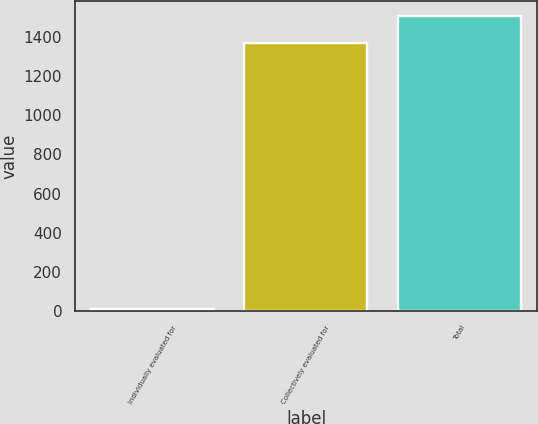Convert chart. <chart><loc_0><loc_0><loc_500><loc_500><bar_chart><fcel>Individually evaluated for<fcel>Collectively evaluated for<fcel>Total<nl><fcel>11<fcel>1369<fcel>1505.9<nl></chart> 